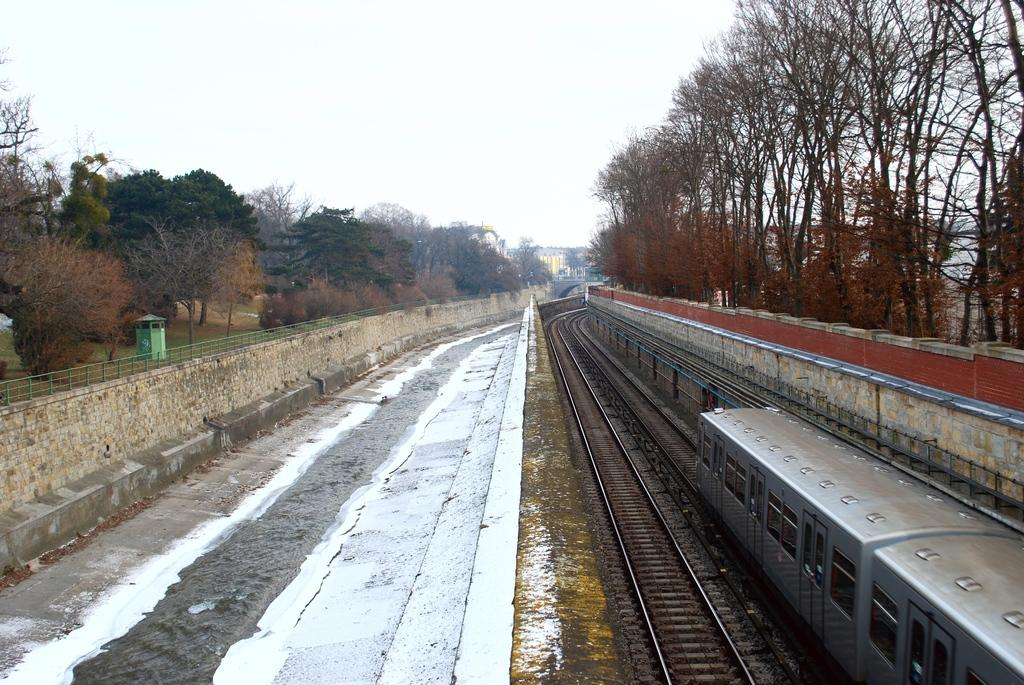What is located on the right side of the image? There is a train on the right side of the image. What is the train's position in relation to the image? The train is on a track. What can be seen in the background of the image? There are trees, walls, buildings, and the sky visible in the background of the image. What is located on the left side of the image? There is a shed on the left side of the image. How many women are looking at the train with their eyes in the image? There are no women or eyes visible in the image; it only features a train, a shed, and various background elements. 